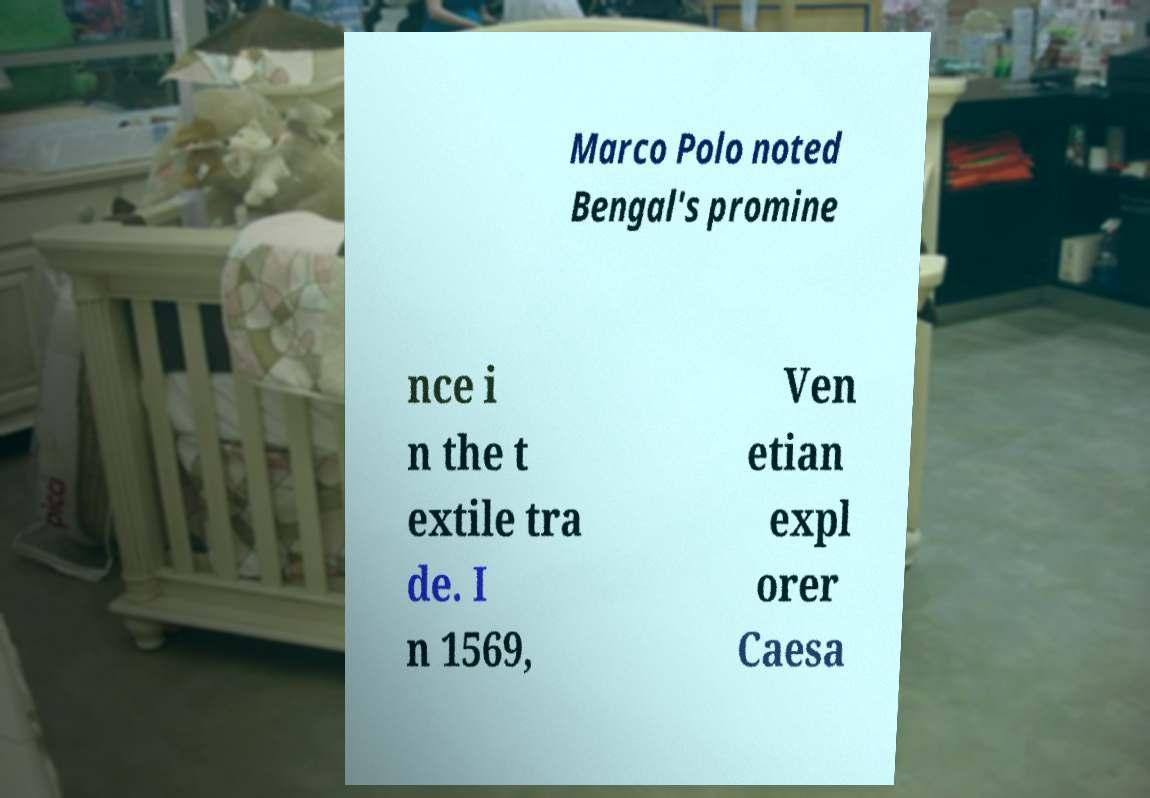What messages or text are displayed in this image? I need them in a readable, typed format. Marco Polo noted Bengal's promine nce i n the t extile tra de. I n 1569, Ven etian expl orer Caesa 